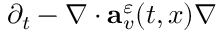Convert formula to latex. <formula><loc_0><loc_0><loc_500><loc_500>\partial _ { t } - \nabla \cdot a _ { v } ^ { \varepsilon } ( t , x ) \nabla</formula> 